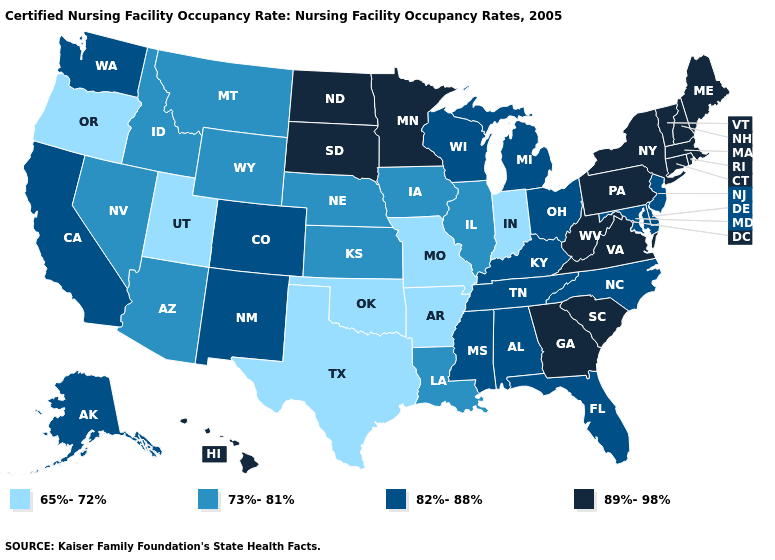What is the value of Massachusetts?
Be succinct. 89%-98%. Does Kentucky have a higher value than Louisiana?
Answer briefly. Yes. What is the value of Nevada?
Concise answer only. 73%-81%. Name the states that have a value in the range 82%-88%?
Give a very brief answer. Alabama, Alaska, California, Colorado, Delaware, Florida, Kentucky, Maryland, Michigan, Mississippi, New Jersey, New Mexico, North Carolina, Ohio, Tennessee, Washington, Wisconsin. What is the value of Vermont?
Answer briefly. 89%-98%. Does Utah have a lower value than North Carolina?
Quick response, please. Yes. What is the value of Virginia?
Concise answer only. 89%-98%. Does Iowa have the lowest value in the USA?
Write a very short answer. No. What is the value of South Dakota?
Keep it brief. 89%-98%. Which states have the lowest value in the South?
Quick response, please. Arkansas, Oklahoma, Texas. What is the value of Florida?
Short answer required. 82%-88%. Does Texas have the lowest value in the South?
Quick response, please. Yes. What is the value of Texas?
Concise answer only. 65%-72%. Name the states that have a value in the range 82%-88%?
Write a very short answer. Alabama, Alaska, California, Colorado, Delaware, Florida, Kentucky, Maryland, Michigan, Mississippi, New Jersey, New Mexico, North Carolina, Ohio, Tennessee, Washington, Wisconsin. Among the states that border Idaho , which have the highest value?
Write a very short answer. Washington. 